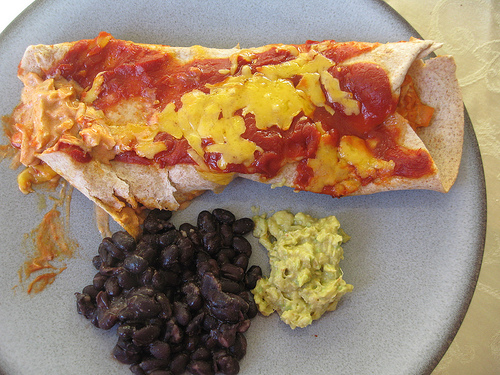<image>
Can you confirm if the burrito is on the beans? No. The burrito is not positioned on the beans. They may be near each other, but the burrito is not supported by or resting on top of the beans. 